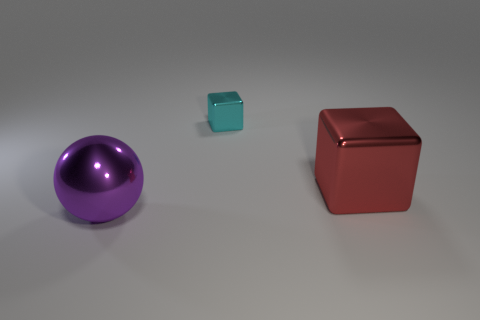What number of cubes are shiny objects or big objects?
Give a very brief answer. 2. What color is the object that is in front of the large red cube?
Give a very brief answer. Purple. How many rubber objects are either small yellow cylinders or large purple things?
Give a very brief answer. 0. The small thing is what color?
Your response must be concise. Cyan. Is there a tiny metallic block in front of the big metal object that is to the right of the big purple metallic thing?
Your response must be concise. No. What is the red cube made of?
Give a very brief answer. Metal. Is the block to the right of the cyan metallic block made of the same material as the thing in front of the large red cube?
Give a very brief answer. Yes. Is there any other thing that has the same color as the tiny shiny cube?
Make the answer very short. No. What is the color of the big metallic object that is the same shape as the tiny metal object?
Ensure brevity in your answer.  Red. What size is the thing that is in front of the small metallic object and behind the large purple thing?
Your response must be concise. Large. 